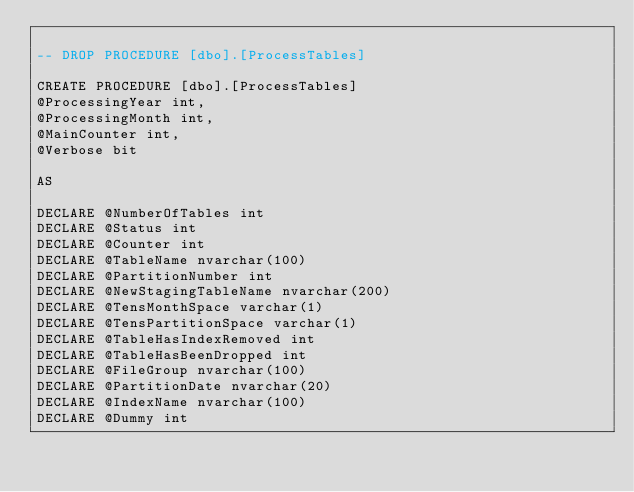Convert code to text. <code><loc_0><loc_0><loc_500><loc_500><_SQL_>
-- DROP PROCEDURE [dbo].[ProcessTables]

CREATE PROCEDURE [dbo].[ProcessTables]
@ProcessingYear int,
@ProcessingMonth int,
@MainCounter int,
@Verbose bit

AS

DECLARE @NumberOfTables int
DECLARE @Status int
DECLARE @Counter int
DECLARE @TableName nvarchar(100)
DECLARE @PartitionNumber int
DECLARE @NewStagingTableName nvarchar(200)
DECLARE @TensMonthSpace varchar(1)
DECLARE @TensPartitionSpace varchar(1)
DECLARE @TableHasIndexRemoved int
DECLARE @TableHasBeenDropped int
DECLARE @FileGroup nvarchar(100)
DECLARE @PartitionDate nvarchar(20)
DECLARE @IndexName nvarchar(100)
DECLARE @Dummy int</code> 